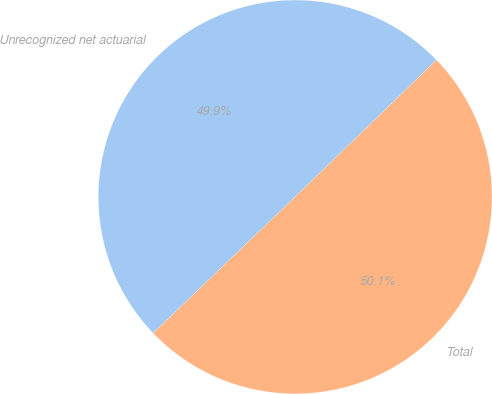Convert chart. <chart><loc_0><loc_0><loc_500><loc_500><pie_chart><fcel>Unrecognized net actuarial<fcel>Total<nl><fcel>49.92%<fcel>50.08%<nl></chart> 